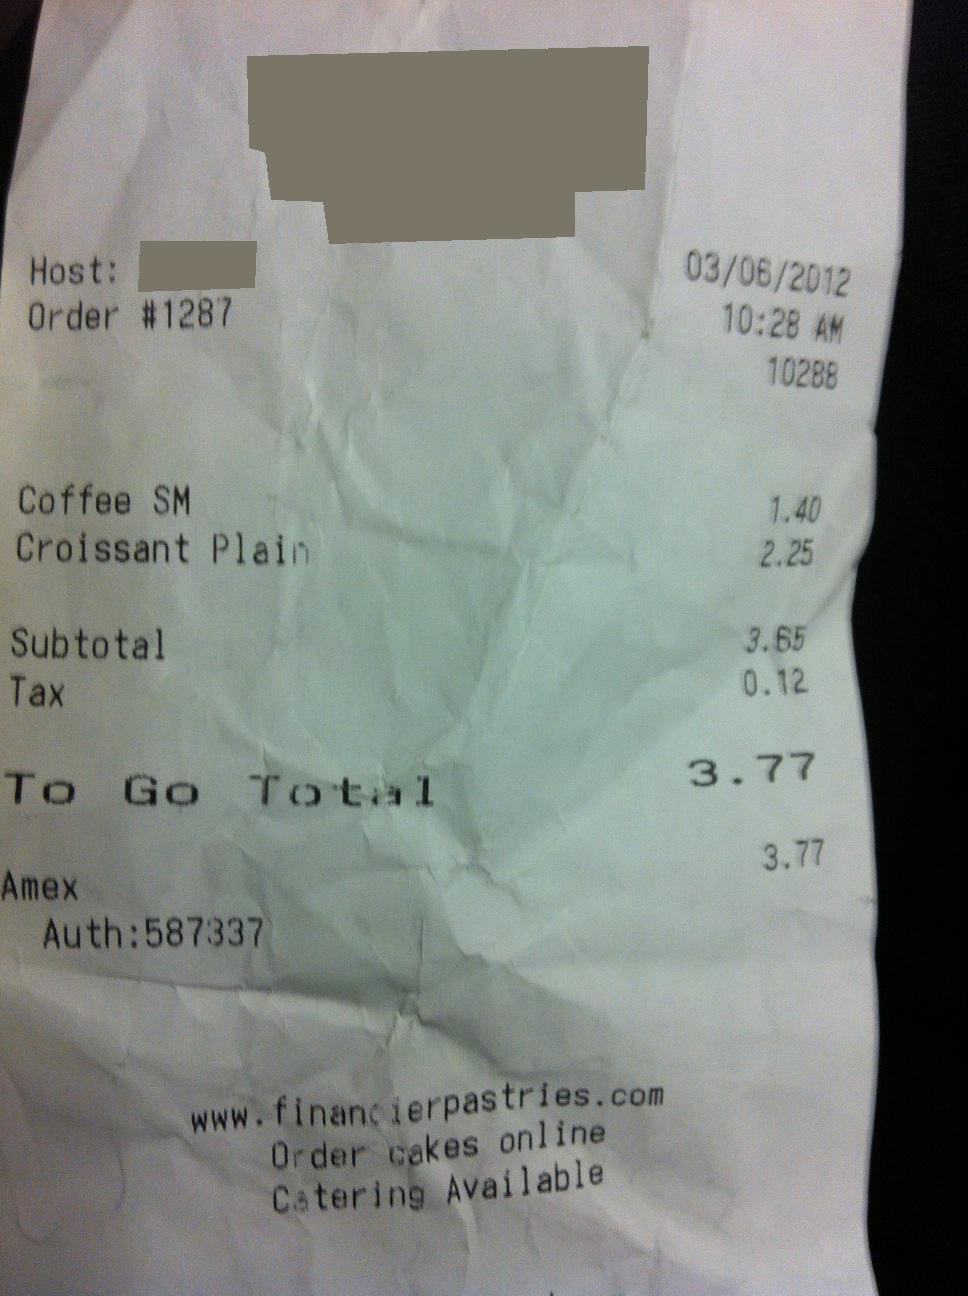How much is the total? The total amount due for the order, as displayed on the receipt, is $3.77. This includes the cost of items purchased before tax, the applicable taxes, and sums up to the final total for payment. 